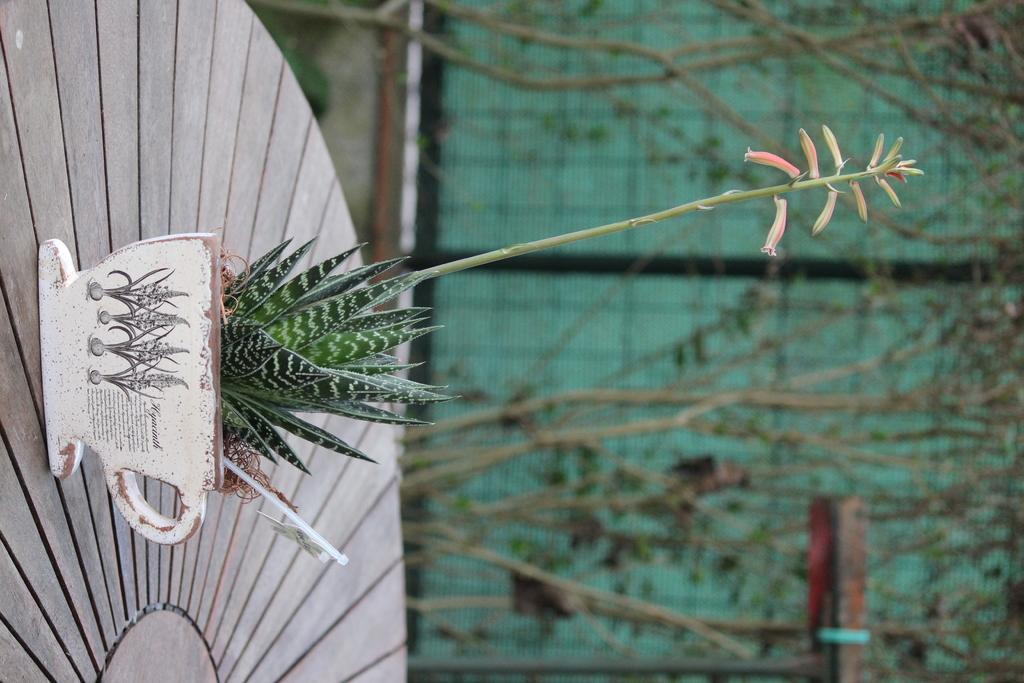What type of plant is visible in the image? There is a small plant in the image. What is the plant placed on? The plant is on a wooden surface. What can be seen in the background of the image? There are trees and a mesh in the background of the image. Where is the pocket located on the plant in the image? There is no pocket present on the plant in the image. What type of steam can be seen coming from the plant in the image? There is no steam present in the image; it is a small plant on a wooden surface with trees and a mesh in the background. 